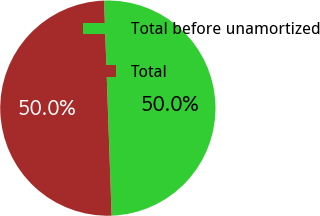Convert chart. <chart><loc_0><loc_0><loc_500><loc_500><pie_chart><fcel>Total before unamortized<fcel>Total<nl><fcel>50.0%<fcel>50.0%<nl></chart> 